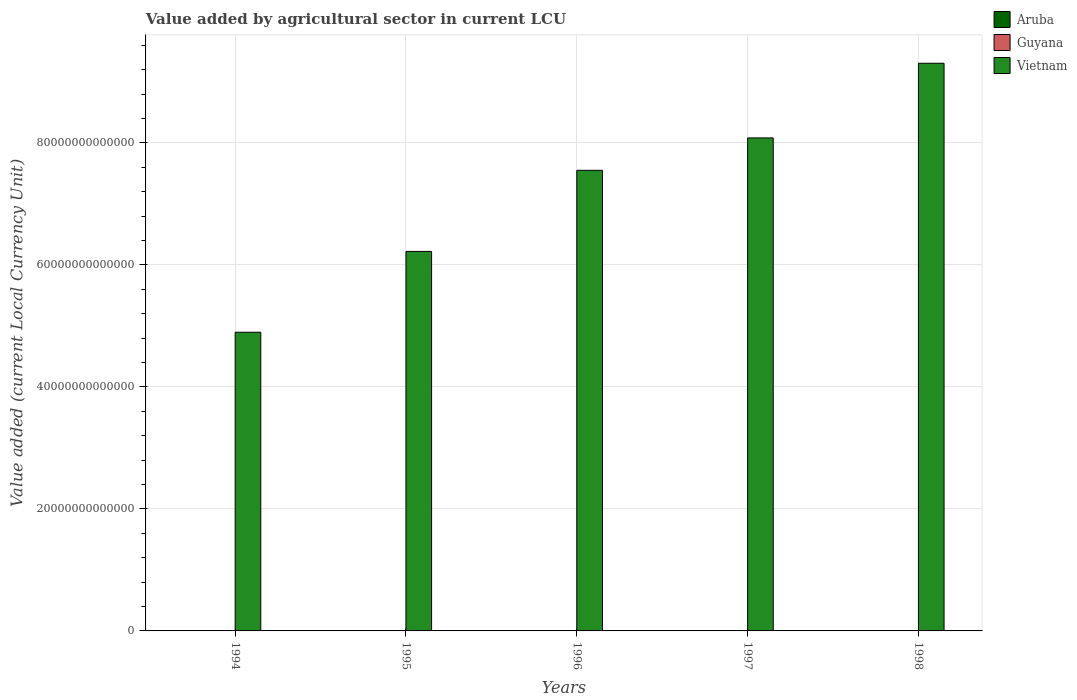How many different coloured bars are there?
Ensure brevity in your answer.  3. Are the number of bars per tick equal to the number of legend labels?
Provide a succinct answer. Yes. What is the value added by agricultural sector in Aruba in 1994?
Keep it short and to the point. 1.20e+07. Across all years, what is the maximum value added by agricultural sector in Guyana?
Your answer should be compact. 3.20e+1. Across all years, what is the minimum value added by agricultural sector in Aruba?
Provide a short and direct response. 1.20e+07. In which year was the value added by agricultural sector in Guyana minimum?
Offer a very short reply. 1994. What is the total value added by agricultural sector in Vietnam in the graph?
Provide a succinct answer. 3.61e+14. What is the difference between the value added by agricultural sector in Vietnam in 1995 and that in 1997?
Provide a short and direct response. -1.86e+13. What is the difference between the value added by agricultural sector in Guyana in 1994 and the value added by agricultural sector in Aruba in 1995?
Ensure brevity in your answer.  2.33e+1. What is the average value added by agricultural sector in Vietnam per year?
Offer a very short reply. 7.21e+13. In the year 1997, what is the difference between the value added by agricultural sector in Guyana and value added by agricultural sector in Vietnam?
Keep it short and to the point. -8.08e+13. In how many years, is the value added by agricultural sector in Aruba greater than 68000000000000 LCU?
Offer a terse response. 0. What is the ratio of the value added by agricultural sector in Aruba in 1995 to that in 1997?
Make the answer very short. 1. Is the value added by agricultural sector in Vietnam in 1996 less than that in 1997?
Keep it short and to the point. Yes. Is the difference between the value added by agricultural sector in Guyana in 1994 and 1996 greater than the difference between the value added by agricultural sector in Vietnam in 1994 and 1996?
Provide a short and direct response. Yes. What is the difference between the highest and the second highest value added by agricultural sector in Vietnam?
Provide a short and direct response. 1.22e+13. What is the difference between the highest and the lowest value added by agricultural sector in Vietnam?
Give a very brief answer. 4.41e+13. Is the sum of the value added by agricultural sector in Aruba in 1994 and 1995 greater than the maximum value added by agricultural sector in Guyana across all years?
Provide a short and direct response. No. What does the 3rd bar from the left in 1996 represents?
Your answer should be very brief. Vietnam. What does the 1st bar from the right in 1997 represents?
Your answer should be compact. Vietnam. Is it the case that in every year, the sum of the value added by agricultural sector in Aruba and value added by agricultural sector in Vietnam is greater than the value added by agricultural sector in Guyana?
Provide a short and direct response. Yes. Are all the bars in the graph horizontal?
Give a very brief answer. No. How many years are there in the graph?
Offer a terse response. 5. What is the difference between two consecutive major ticks on the Y-axis?
Your answer should be compact. 2.00e+13. How many legend labels are there?
Provide a short and direct response. 3. How are the legend labels stacked?
Provide a succinct answer. Vertical. What is the title of the graph?
Your answer should be very brief. Value added by agricultural sector in current LCU. What is the label or title of the Y-axis?
Ensure brevity in your answer.  Value added (current Local Currency Unit). What is the Value added (current Local Currency Unit) of Guyana in 1994?
Give a very brief answer. 2.34e+1. What is the Value added (current Local Currency Unit) in Vietnam in 1994?
Your response must be concise. 4.90e+13. What is the Value added (current Local Currency Unit) in Guyana in 1995?
Your response must be concise. 3.05e+1. What is the Value added (current Local Currency Unit) in Vietnam in 1995?
Ensure brevity in your answer.  6.22e+13. What is the Value added (current Local Currency Unit) of Aruba in 1996?
Give a very brief answer. 1.20e+07. What is the Value added (current Local Currency Unit) of Guyana in 1996?
Your answer should be very brief. 3.20e+1. What is the Value added (current Local Currency Unit) of Vietnam in 1996?
Provide a succinct answer. 7.55e+13. What is the Value added (current Local Currency Unit) of Aruba in 1997?
Keep it short and to the point. 1.20e+07. What is the Value added (current Local Currency Unit) in Guyana in 1997?
Your answer should be very brief. 3.18e+1. What is the Value added (current Local Currency Unit) in Vietnam in 1997?
Offer a very short reply. 8.08e+13. What is the Value added (current Local Currency Unit) of Guyana in 1998?
Your response must be concise. 3.13e+1. What is the Value added (current Local Currency Unit) in Vietnam in 1998?
Provide a succinct answer. 9.31e+13. Across all years, what is the maximum Value added (current Local Currency Unit) in Aruba?
Ensure brevity in your answer.  1.20e+07. Across all years, what is the maximum Value added (current Local Currency Unit) in Guyana?
Keep it short and to the point. 3.20e+1. Across all years, what is the maximum Value added (current Local Currency Unit) in Vietnam?
Offer a very short reply. 9.31e+13. Across all years, what is the minimum Value added (current Local Currency Unit) of Aruba?
Give a very brief answer. 1.20e+07. Across all years, what is the minimum Value added (current Local Currency Unit) of Guyana?
Your answer should be compact. 2.34e+1. Across all years, what is the minimum Value added (current Local Currency Unit) in Vietnam?
Offer a very short reply. 4.90e+13. What is the total Value added (current Local Currency Unit) of Aruba in the graph?
Make the answer very short. 6.00e+07. What is the total Value added (current Local Currency Unit) in Guyana in the graph?
Offer a terse response. 1.49e+11. What is the total Value added (current Local Currency Unit) of Vietnam in the graph?
Your response must be concise. 3.61e+14. What is the difference between the Value added (current Local Currency Unit) of Aruba in 1994 and that in 1995?
Your answer should be compact. 0. What is the difference between the Value added (current Local Currency Unit) of Guyana in 1994 and that in 1995?
Provide a short and direct response. -7.12e+09. What is the difference between the Value added (current Local Currency Unit) of Vietnam in 1994 and that in 1995?
Provide a short and direct response. -1.33e+13. What is the difference between the Value added (current Local Currency Unit) of Guyana in 1994 and that in 1996?
Your answer should be very brief. -8.64e+09. What is the difference between the Value added (current Local Currency Unit) in Vietnam in 1994 and that in 1996?
Your response must be concise. -2.65e+13. What is the difference between the Value added (current Local Currency Unit) in Aruba in 1994 and that in 1997?
Keep it short and to the point. 0. What is the difference between the Value added (current Local Currency Unit) of Guyana in 1994 and that in 1997?
Provide a succinct answer. -8.46e+09. What is the difference between the Value added (current Local Currency Unit) of Vietnam in 1994 and that in 1997?
Offer a very short reply. -3.19e+13. What is the difference between the Value added (current Local Currency Unit) in Guyana in 1994 and that in 1998?
Your answer should be compact. -7.95e+09. What is the difference between the Value added (current Local Currency Unit) of Vietnam in 1994 and that in 1998?
Ensure brevity in your answer.  -4.41e+13. What is the difference between the Value added (current Local Currency Unit) in Aruba in 1995 and that in 1996?
Make the answer very short. 0. What is the difference between the Value added (current Local Currency Unit) of Guyana in 1995 and that in 1996?
Provide a short and direct response. -1.51e+09. What is the difference between the Value added (current Local Currency Unit) of Vietnam in 1995 and that in 1996?
Your answer should be very brief. -1.33e+13. What is the difference between the Value added (current Local Currency Unit) in Aruba in 1995 and that in 1997?
Offer a very short reply. 0. What is the difference between the Value added (current Local Currency Unit) in Guyana in 1995 and that in 1997?
Provide a succinct answer. -1.33e+09. What is the difference between the Value added (current Local Currency Unit) of Vietnam in 1995 and that in 1997?
Your response must be concise. -1.86e+13. What is the difference between the Value added (current Local Currency Unit) of Aruba in 1995 and that in 1998?
Ensure brevity in your answer.  0. What is the difference between the Value added (current Local Currency Unit) of Guyana in 1995 and that in 1998?
Your answer should be very brief. -8.28e+08. What is the difference between the Value added (current Local Currency Unit) of Vietnam in 1995 and that in 1998?
Your answer should be very brief. -3.08e+13. What is the difference between the Value added (current Local Currency Unit) of Aruba in 1996 and that in 1997?
Your answer should be compact. 0. What is the difference between the Value added (current Local Currency Unit) in Guyana in 1996 and that in 1997?
Ensure brevity in your answer.  1.80e+08. What is the difference between the Value added (current Local Currency Unit) of Vietnam in 1996 and that in 1997?
Your response must be concise. -5.31e+12. What is the difference between the Value added (current Local Currency Unit) of Aruba in 1996 and that in 1998?
Your answer should be compact. 0. What is the difference between the Value added (current Local Currency Unit) in Guyana in 1996 and that in 1998?
Your response must be concise. 6.84e+08. What is the difference between the Value added (current Local Currency Unit) of Vietnam in 1996 and that in 1998?
Your answer should be compact. -1.76e+13. What is the difference between the Value added (current Local Currency Unit) of Guyana in 1997 and that in 1998?
Your response must be concise. 5.04e+08. What is the difference between the Value added (current Local Currency Unit) of Vietnam in 1997 and that in 1998?
Provide a succinct answer. -1.22e+13. What is the difference between the Value added (current Local Currency Unit) of Aruba in 1994 and the Value added (current Local Currency Unit) of Guyana in 1995?
Provide a succinct answer. -3.05e+1. What is the difference between the Value added (current Local Currency Unit) of Aruba in 1994 and the Value added (current Local Currency Unit) of Vietnam in 1995?
Your answer should be very brief. -6.22e+13. What is the difference between the Value added (current Local Currency Unit) in Guyana in 1994 and the Value added (current Local Currency Unit) in Vietnam in 1995?
Provide a succinct answer. -6.22e+13. What is the difference between the Value added (current Local Currency Unit) in Aruba in 1994 and the Value added (current Local Currency Unit) in Guyana in 1996?
Your answer should be very brief. -3.20e+1. What is the difference between the Value added (current Local Currency Unit) in Aruba in 1994 and the Value added (current Local Currency Unit) in Vietnam in 1996?
Your response must be concise. -7.55e+13. What is the difference between the Value added (current Local Currency Unit) in Guyana in 1994 and the Value added (current Local Currency Unit) in Vietnam in 1996?
Provide a succinct answer. -7.55e+13. What is the difference between the Value added (current Local Currency Unit) of Aruba in 1994 and the Value added (current Local Currency Unit) of Guyana in 1997?
Ensure brevity in your answer.  -3.18e+1. What is the difference between the Value added (current Local Currency Unit) of Aruba in 1994 and the Value added (current Local Currency Unit) of Vietnam in 1997?
Your response must be concise. -8.08e+13. What is the difference between the Value added (current Local Currency Unit) of Guyana in 1994 and the Value added (current Local Currency Unit) of Vietnam in 1997?
Ensure brevity in your answer.  -8.08e+13. What is the difference between the Value added (current Local Currency Unit) of Aruba in 1994 and the Value added (current Local Currency Unit) of Guyana in 1998?
Your answer should be compact. -3.13e+1. What is the difference between the Value added (current Local Currency Unit) in Aruba in 1994 and the Value added (current Local Currency Unit) in Vietnam in 1998?
Your response must be concise. -9.31e+13. What is the difference between the Value added (current Local Currency Unit) in Guyana in 1994 and the Value added (current Local Currency Unit) in Vietnam in 1998?
Provide a short and direct response. -9.30e+13. What is the difference between the Value added (current Local Currency Unit) of Aruba in 1995 and the Value added (current Local Currency Unit) of Guyana in 1996?
Offer a very short reply. -3.20e+1. What is the difference between the Value added (current Local Currency Unit) of Aruba in 1995 and the Value added (current Local Currency Unit) of Vietnam in 1996?
Your response must be concise. -7.55e+13. What is the difference between the Value added (current Local Currency Unit) of Guyana in 1995 and the Value added (current Local Currency Unit) of Vietnam in 1996?
Your answer should be compact. -7.55e+13. What is the difference between the Value added (current Local Currency Unit) of Aruba in 1995 and the Value added (current Local Currency Unit) of Guyana in 1997?
Ensure brevity in your answer.  -3.18e+1. What is the difference between the Value added (current Local Currency Unit) in Aruba in 1995 and the Value added (current Local Currency Unit) in Vietnam in 1997?
Provide a short and direct response. -8.08e+13. What is the difference between the Value added (current Local Currency Unit) in Guyana in 1995 and the Value added (current Local Currency Unit) in Vietnam in 1997?
Make the answer very short. -8.08e+13. What is the difference between the Value added (current Local Currency Unit) of Aruba in 1995 and the Value added (current Local Currency Unit) of Guyana in 1998?
Offer a very short reply. -3.13e+1. What is the difference between the Value added (current Local Currency Unit) in Aruba in 1995 and the Value added (current Local Currency Unit) in Vietnam in 1998?
Your answer should be very brief. -9.31e+13. What is the difference between the Value added (current Local Currency Unit) in Guyana in 1995 and the Value added (current Local Currency Unit) in Vietnam in 1998?
Offer a terse response. -9.30e+13. What is the difference between the Value added (current Local Currency Unit) of Aruba in 1996 and the Value added (current Local Currency Unit) of Guyana in 1997?
Ensure brevity in your answer.  -3.18e+1. What is the difference between the Value added (current Local Currency Unit) of Aruba in 1996 and the Value added (current Local Currency Unit) of Vietnam in 1997?
Offer a very short reply. -8.08e+13. What is the difference between the Value added (current Local Currency Unit) in Guyana in 1996 and the Value added (current Local Currency Unit) in Vietnam in 1997?
Offer a terse response. -8.08e+13. What is the difference between the Value added (current Local Currency Unit) of Aruba in 1996 and the Value added (current Local Currency Unit) of Guyana in 1998?
Keep it short and to the point. -3.13e+1. What is the difference between the Value added (current Local Currency Unit) in Aruba in 1996 and the Value added (current Local Currency Unit) in Vietnam in 1998?
Offer a very short reply. -9.31e+13. What is the difference between the Value added (current Local Currency Unit) in Guyana in 1996 and the Value added (current Local Currency Unit) in Vietnam in 1998?
Offer a very short reply. -9.30e+13. What is the difference between the Value added (current Local Currency Unit) of Aruba in 1997 and the Value added (current Local Currency Unit) of Guyana in 1998?
Your answer should be very brief. -3.13e+1. What is the difference between the Value added (current Local Currency Unit) in Aruba in 1997 and the Value added (current Local Currency Unit) in Vietnam in 1998?
Make the answer very short. -9.31e+13. What is the difference between the Value added (current Local Currency Unit) in Guyana in 1997 and the Value added (current Local Currency Unit) in Vietnam in 1998?
Give a very brief answer. -9.30e+13. What is the average Value added (current Local Currency Unit) in Aruba per year?
Your response must be concise. 1.20e+07. What is the average Value added (current Local Currency Unit) of Guyana per year?
Give a very brief answer. 2.98e+1. What is the average Value added (current Local Currency Unit) of Vietnam per year?
Your answer should be very brief. 7.21e+13. In the year 1994, what is the difference between the Value added (current Local Currency Unit) in Aruba and Value added (current Local Currency Unit) in Guyana?
Your response must be concise. -2.33e+1. In the year 1994, what is the difference between the Value added (current Local Currency Unit) of Aruba and Value added (current Local Currency Unit) of Vietnam?
Make the answer very short. -4.90e+13. In the year 1994, what is the difference between the Value added (current Local Currency Unit) in Guyana and Value added (current Local Currency Unit) in Vietnam?
Provide a succinct answer. -4.89e+13. In the year 1995, what is the difference between the Value added (current Local Currency Unit) of Aruba and Value added (current Local Currency Unit) of Guyana?
Keep it short and to the point. -3.05e+1. In the year 1995, what is the difference between the Value added (current Local Currency Unit) in Aruba and Value added (current Local Currency Unit) in Vietnam?
Make the answer very short. -6.22e+13. In the year 1995, what is the difference between the Value added (current Local Currency Unit) in Guyana and Value added (current Local Currency Unit) in Vietnam?
Your response must be concise. -6.22e+13. In the year 1996, what is the difference between the Value added (current Local Currency Unit) in Aruba and Value added (current Local Currency Unit) in Guyana?
Your answer should be very brief. -3.20e+1. In the year 1996, what is the difference between the Value added (current Local Currency Unit) in Aruba and Value added (current Local Currency Unit) in Vietnam?
Your response must be concise. -7.55e+13. In the year 1996, what is the difference between the Value added (current Local Currency Unit) in Guyana and Value added (current Local Currency Unit) in Vietnam?
Your response must be concise. -7.55e+13. In the year 1997, what is the difference between the Value added (current Local Currency Unit) of Aruba and Value added (current Local Currency Unit) of Guyana?
Offer a very short reply. -3.18e+1. In the year 1997, what is the difference between the Value added (current Local Currency Unit) of Aruba and Value added (current Local Currency Unit) of Vietnam?
Give a very brief answer. -8.08e+13. In the year 1997, what is the difference between the Value added (current Local Currency Unit) in Guyana and Value added (current Local Currency Unit) in Vietnam?
Provide a succinct answer. -8.08e+13. In the year 1998, what is the difference between the Value added (current Local Currency Unit) in Aruba and Value added (current Local Currency Unit) in Guyana?
Give a very brief answer. -3.13e+1. In the year 1998, what is the difference between the Value added (current Local Currency Unit) of Aruba and Value added (current Local Currency Unit) of Vietnam?
Your answer should be compact. -9.31e+13. In the year 1998, what is the difference between the Value added (current Local Currency Unit) in Guyana and Value added (current Local Currency Unit) in Vietnam?
Keep it short and to the point. -9.30e+13. What is the ratio of the Value added (current Local Currency Unit) in Guyana in 1994 to that in 1995?
Your response must be concise. 0.77. What is the ratio of the Value added (current Local Currency Unit) of Vietnam in 1994 to that in 1995?
Make the answer very short. 0.79. What is the ratio of the Value added (current Local Currency Unit) in Aruba in 1994 to that in 1996?
Your answer should be very brief. 1. What is the ratio of the Value added (current Local Currency Unit) in Guyana in 1994 to that in 1996?
Keep it short and to the point. 0.73. What is the ratio of the Value added (current Local Currency Unit) of Vietnam in 1994 to that in 1996?
Offer a terse response. 0.65. What is the ratio of the Value added (current Local Currency Unit) in Aruba in 1994 to that in 1997?
Your answer should be very brief. 1. What is the ratio of the Value added (current Local Currency Unit) of Guyana in 1994 to that in 1997?
Provide a succinct answer. 0.73. What is the ratio of the Value added (current Local Currency Unit) of Vietnam in 1994 to that in 1997?
Your response must be concise. 0.61. What is the ratio of the Value added (current Local Currency Unit) of Aruba in 1994 to that in 1998?
Offer a terse response. 1. What is the ratio of the Value added (current Local Currency Unit) of Guyana in 1994 to that in 1998?
Offer a very short reply. 0.75. What is the ratio of the Value added (current Local Currency Unit) of Vietnam in 1994 to that in 1998?
Your response must be concise. 0.53. What is the ratio of the Value added (current Local Currency Unit) in Aruba in 1995 to that in 1996?
Offer a terse response. 1. What is the ratio of the Value added (current Local Currency Unit) of Guyana in 1995 to that in 1996?
Your answer should be compact. 0.95. What is the ratio of the Value added (current Local Currency Unit) in Vietnam in 1995 to that in 1996?
Make the answer very short. 0.82. What is the ratio of the Value added (current Local Currency Unit) in Guyana in 1995 to that in 1997?
Ensure brevity in your answer.  0.96. What is the ratio of the Value added (current Local Currency Unit) of Vietnam in 1995 to that in 1997?
Keep it short and to the point. 0.77. What is the ratio of the Value added (current Local Currency Unit) of Guyana in 1995 to that in 1998?
Provide a short and direct response. 0.97. What is the ratio of the Value added (current Local Currency Unit) of Vietnam in 1995 to that in 1998?
Ensure brevity in your answer.  0.67. What is the ratio of the Value added (current Local Currency Unit) in Guyana in 1996 to that in 1997?
Give a very brief answer. 1.01. What is the ratio of the Value added (current Local Currency Unit) in Vietnam in 1996 to that in 1997?
Ensure brevity in your answer.  0.93. What is the ratio of the Value added (current Local Currency Unit) in Guyana in 1996 to that in 1998?
Make the answer very short. 1.02. What is the ratio of the Value added (current Local Currency Unit) of Vietnam in 1996 to that in 1998?
Offer a very short reply. 0.81. What is the ratio of the Value added (current Local Currency Unit) in Guyana in 1997 to that in 1998?
Your answer should be very brief. 1.02. What is the ratio of the Value added (current Local Currency Unit) of Vietnam in 1997 to that in 1998?
Offer a very short reply. 0.87. What is the difference between the highest and the second highest Value added (current Local Currency Unit) of Aruba?
Offer a terse response. 0. What is the difference between the highest and the second highest Value added (current Local Currency Unit) in Guyana?
Make the answer very short. 1.80e+08. What is the difference between the highest and the second highest Value added (current Local Currency Unit) of Vietnam?
Offer a very short reply. 1.22e+13. What is the difference between the highest and the lowest Value added (current Local Currency Unit) in Aruba?
Your answer should be very brief. 0. What is the difference between the highest and the lowest Value added (current Local Currency Unit) of Guyana?
Keep it short and to the point. 8.64e+09. What is the difference between the highest and the lowest Value added (current Local Currency Unit) of Vietnam?
Give a very brief answer. 4.41e+13. 